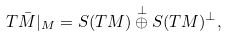<formula> <loc_0><loc_0><loc_500><loc_500>T \bar { M } | _ { M } = S ( T M ) \overset { \bot } { \oplus } S ( T M ) ^ { \bot } ,</formula> 